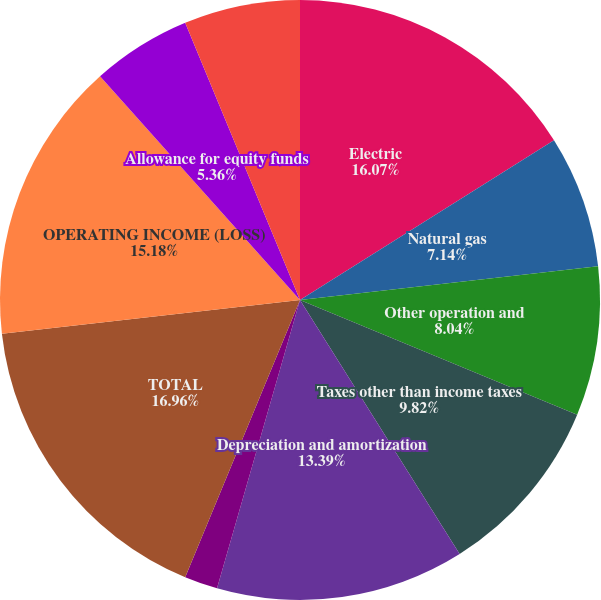<chart> <loc_0><loc_0><loc_500><loc_500><pie_chart><fcel>Electric<fcel>Natural gas<fcel>Other operation and<fcel>Taxes other than income taxes<fcel>Depreciation and amortization<fcel>Other regulatory charges<fcel>TOTAL<fcel>OPERATING INCOME (LOSS)<fcel>Allowance for equity funds<fcel>Interest and investment income<nl><fcel>16.07%<fcel>7.14%<fcel>8.04%<fcel>9.82%<fcel>13.39%<fcel>1.79%<fcel>16.96%<fcel>15.18%<fcel>5.36%<fcel>6.25%<nl></chart> 